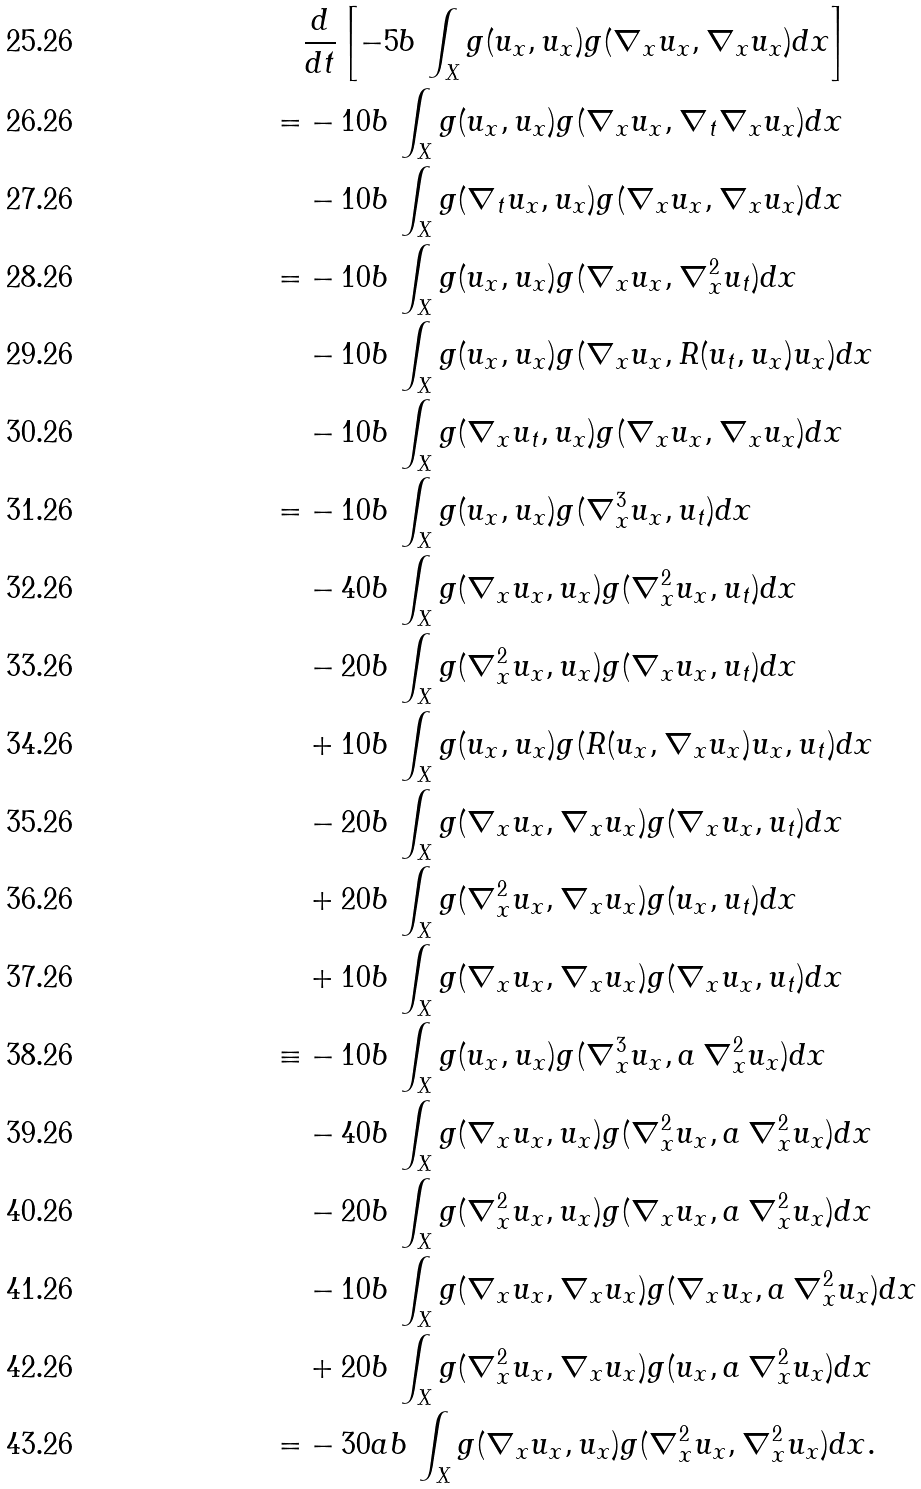<formula> <loc_0><loc_0><loc_500><loc_500>& \frac { d } { d t } \left [ - 5 b \, \int _ { X } g ( u _ { x } , u _ { x } ) g ( \nabla _ { x } u _ { x } , \nabla _ { x } u _ { x } ) d x \right ] \\ = & - 1 0 b \, \int _ { X } g ( u _ { x } , u _ { x } ) g ( \nabla _ { x } u _ { x } , \nabla _ { t } \nabla _ { x } u _ { x } ) d x \\ & - 1 0 b \, \int _ { X } g ( \nabla _ { t } u _ { x } , u _ { x } ) g ( \nabla _ { x } u _ { x } , \nabla _ { x } u _ { x } ) d x \\ = & - 1 0 b \, \int _ { X } g ( u _ { x } , u _ { x } ) g ( \nabla _ { x } u _ { x } , \nabla _ { x } ^ { 2 } u _ { t } ) d x \\ & - 1 0 b \, \int _ { X } g ( u _ { x } , u _ { x } ) g ( \nabla _ { x } u _ { x } , R ( u _ { t } , u _ { x } ) u _ { x } ) d x \\ & - 1 0 b \, \int _ { X } g ( \nabla _ { x } u _ { t } , u _ { x } ) g ( \nabla _ { x } u _ { x } , \nabla _ { x } u _ { x } ) d x \\ = & - 1 0 b \, \int _ { X } g ( u _ { x } , u _ { x } ) g ( \nabla _ { x } ^ { 3 } u _ { x } , u _ { t } ) d x \\ & - 4 0 b \, \int _ { X } g ( \nabla _ { x } u _ { x } , u _ { x } ) g ( \nabla _ { x } ^ { 2 } u _ { x } , u _ { t } ) d x \\ & - 2 0 b \, \int _ { X } g ( \nabla _ { x } ^ { 2 } u _ { x } , u _ { x } ) g ( \nabla _ { x } u _ { x } , u _ { t } ) d x \\ & + 1 0 b \, \int _ { X } g ( u _ { x } , u _ { x } ) g ( R ( u _ { x } , \nabla _ { x } u _ { x } ) u _ { x } , u _ { t } ) d x \\ & - 2 0 b \, \int _ { X } g ( \nabla _ { x } u _ { x } , \nabla _ { x } u _ { x } ) g ( \nabla _ { x } u _ { x } , u _ { t } ) d x \\ & + 2 0 b \, \int _ { X } g ( \nabla _ { x } ^ { 2 } u _ { x } , \nabla _ { x } u _ { x } ) g ( u _ { x } , u _ { t } ) d x \\ & + 1 0 b \, \int _ { X } g ( \nabla _ { x } u _ { x } , \nabla _ { x } u _ { x } ) g ( \nabla _ { x } u _ { x } , u _ { t } ) d x \\ \equiv & - 1 0 b \, \int _ { X } g ( u _ { x } , u _ { x } ) g ( \nabla _ { x } ^ { 3 } u _ { x } , a \, \nabla _ { x } ^ { 2 } u _ { x } ) d x \\ & - 4 0 b \, \int _ { X } g ( \nabla _ { x } u _ { x } , u _ { x } ) g ( \nabla _ { x } ^ { 2 } u _ { x } , a \, \nabla _ { x } ^ { 2 } u _ { x } ) d x \\ & - 2 0 b \, \int _ { X } g ( \nabla _ { x } ^ { 2 } u _ { x } , u _ { x } ) g ( \nabla _ { x } u _ { x } , a \, \nabla _ { x } ^ { 2 } u _ { x } ) d x \\ & - 1 0 b \, \int _ { X } g ( \nabla _ { x } u _ { x } , \nabla _ { x } u _ { x } ) g ( \nabla _ { x } u _ { x } , a \, \nabla _ { x } ^ { 2 } u _ { x } ) d x \\ & + 2 0 b \, \int _ { X } g ( \nabla _ { x } ^ { 2 } u _ { x } , \nabla _ { x } u _ { x } ) g ( u _ { x } , a \, \nabla _ { x } ^ { 2 } u _ { x } ) d x \\ = & - 3 0 a b \, \int _ { X } g ( \nabla _ { x } u _ { x } , u _ { x } ) g ( \nabla _ { x } ^ { 2 } u _ { x } , \nabla _ { x } ^ { 2 } u _ { x } ) d x .</formula> 